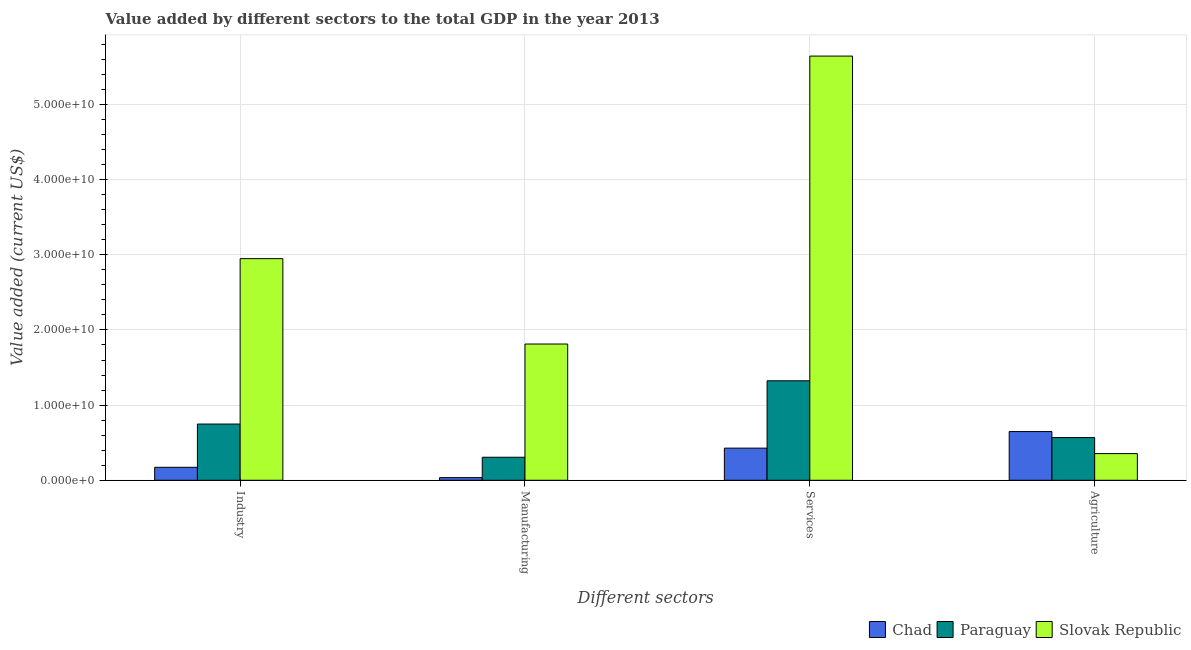How many groups of bars are there?
Ensure brevity in your answer.  4. Are the number of bars per tick equal to the number of legend labels?
Provide a short and direct response. Yes. Are the number of bars on each tick of the X-axis equal?
Give a very brief answer. Yes. How many bars are there on the 1st tick from the left?
Make the answer very short. 3. What is the label of the 4th group of bars from the left?
Your answer should be compact. Agriculture. What is the value added by manufacturing sector in Slovak Republic?
Give a very brief answer. 1.81e+1. Across all countries, what is the maximum value added by services sector?
Offer a terse response. 5.64e+1. Across all countries, what is the minimum value added by manufacturing sector?
Your response must be concise. 3.52e+08. In which country was the value added by agricultural sector maximum?
Keep it short and to the point. Chad. In which country was the value added by agricultural sector minimum?
Keep it short and to the point. Slovak Republic. What is the total value added by manufacturing sector in the graph?
Your answer should be very brief. 2.15e+1. What is the difference between the value added by services sector in Paraguay and that in Slovak Republic?
Provide a short and direct response. -4.32e+1. What is the difference between the value added by industrial sector in Slovak Republic and the value added by agricultural sector in Paraguay?
Provide a short and direct response. 2.38e+1. What is the average value added by agricultural sector per country?
Make the answer very short. 5.24e+09. What is the difference between the value added by services sector and value added by industrial sector in Slovak Republic?
Ensure brevity in your answer.  2.69e+1. What is the ratio of the value added by services sector in Chad to that in Slovak Republic?
Your answer should be very brief. 0.08. What is the difference between the highest and the second highest value added by industrial sector?
Keep it short and to the point. 2.20e+1. What is the difference between the highest and the lowest value added by manufacturing sector?
Ensure brevity in your answer.  1.78e+1. In how many countries, is the value added by services sector greater than the average value added by services sector taken over all countries?
Your response must be concise. 1. Is the sum of the value added by agricultural sector in Chad and Slovak Republic greater than the maximum value added by industrial sector across all countries?
Your answer should be very brief. No. Is it the case that in every country, the sum of the value added by manufacturing sector and value added by agricultural sector is greater than the sum of value added by services sector and value added by industrial sector?
Your answer should be compact. No. What does the 1st bar from the left in Services represents?
Offer a very short reply. Chad. What does the 2nd bar from the right in Industry represents?
Your response must be concise. Paraguay. Is it the case that in every country, the sum of the value added by industrial sector and value added by manufacturing sector is greater than the value added by services sector?
Provide a short and direct response. No. Are all the bars in the graph horizontal?
Keep it short and to the point. No. How many countries are there in the graph?
Your answer should be compact. 3. What is the difference between two consecutive major ticks on the Y-axis?
Make the answer very short. 1.00e+1. Are the values on the major ticks of Y-axis written in scientific E-notation?
Ensure brevity in your answer.  Yes. Does the graph contain grids?
Provide a short and direct response. Yes. How many legend labels are there?
Ensure brevity in your answer.  3. What is the title of the graph?
Ensure brevity in your answer.  Value added by different sectors to the total GDP in the year 2013. Does "Cote d'Ivoire" appear as one of the legend labels in the graph?
Offer a terse response. No. What is the label or title of the X-axis?
Offer a terse response. Different sectors. What is the label or title of the Y-axis?
Your response must be concise. Value added (current US$). What is the Value added (current US$) of Chad in Industry?
Make the answer very short. 1.73e+09. What is the Value added (current US$) of Paraguay in Industry?
Provide a short and direct response. 7.48e+09. What is the Value added (current US$) of Slovak Republic in Industry?
Offer a very short reply. 2.95e+1. What is the Value added (current US$) of Chad in Manufacturing?
Make the answer very short. 3.52e+08. What is the Value added (current US$) of Paraguay in Manufacturing?
Ensure brevity in your answer.  3.06e+09. What is the Value added (current US$) of Slovak Republic in Manufacturing?
Your answer should be very brief. 1.81e+1. What is the Value added (current US$) in Chad in Services?
Your answer should be very brief. 4.28e+09. What is the Value added (current US$) in Paraguay in Services?
Ensure brevity in your answer.  1.32e+1. What is the Value added (current US$) of Slovak Republic in Services?
Offer a very short reply. 5.64e+1. What is the Value added (current US$) in Chad in Agriculture?
Your response must be concise. 6.48e+09. What is the Value added (current US$) in Paraguay in Agriculture?
Your answer should be very brief. 5.68e+09. What is the Value added (current US$) in Slovak Republic in Agriculture?
Your answer should be compact. 3.55e+09. Across all Different sectors, what is the maximum Value added (current US$) in Chad?
Keep it short and to the point. 6.48e+09. Across all Different sectors, what is the maximum Value added (current US$) of Paraguay?
Provide a succinct answer. 1.32e+1. Across all Different sectors, what is the maximum Value added (current US$) in Slovak Republic?
Provide a short and direct response. 5.64e+1. Across all Different sectors, what is the minimum Value added (current US$) of Chad?
Provide a short and direct response. 3.52e+08. Across all Different sectors, what is the minimum Value added (current US$) in Paraguay?
Your answer should be compact. 3.06e+09. Across all Different sectors, what is the minimum Value added (current US$) in Slovak Republic?
Offer a terse response. 3.55e+09. What is the total Value added (current US$) of Chad in the graph?
Provide a succinct answer. 1.28e+1. What is the total Value added (current US$) of Paraguay in the graph?
Give a very brief answer. 2.95e+1. What is the total Value added (current US$) in Slovak Republic in the graph?
Your answer should be compact. 1.08e+11. What is the difference between the Value added (current US$) of Chad in Industry and that in Manufacturing?
Your response must be concise. 1.37e+09. What is the difference between the Value added (current US$) in Paraguay in Industry and that in Manufacturing?
Offer a very short reply. 4.42e+09. What is the difference between the Value added (current US$) of Slovak Republic in Industry and that in Manufacturing?
Offer a very short reply. 1.14e+1. What is the difference between the Value added (current US$) of Chad in Industry and that in Services?
Your answer should be compact. -2.55e+09. What is the difference between the Value added (current US$) of Paraguay in Industry and that in Services?
Your response must be concise. -5.75e+09. What is the difference between the Value added (current US$) in Slovak Republic in Industry and that in Services?
Provide a succinct answer. -2.69e+1. What is the difference between the Value added (current US$) in Chad in Industry and that in Agriculture?
Offer a terse response. -4.75e+09. What is the difference between the Value added (current US$) of Paraguay in Industry and that in Agriculture?
Keep it short and to the point. 1.80e+09. What is the difference between the Value added (current US$) of Slovak Republic in Industry and that in Agriculture?
Ensure brevity in your answer.  2.59e+1. What is the difference between the Value added (current US$) of Chad in Manufacturing and that in Services?
Provide a short and direct response. -3.92e+09. What is the difference between the Value added (current US$) of Paraguay in Manufacturing and that in Services?
Give a very brief answer. -1.02e+1. What is the difference between the Value added (current US$) in Slovak Republic in Manufacturing and that in Services?
Give a very brief answer. -3.83e+1. What is the difference between the Value added (current US$) of Chad in Manufacturing and that in Agriculture?
Your response must be concise. -6.13e+09. What is the difference between the Value added (current US$) of Paraguay in Manufacturing and that in Agriculture?
Ensure brevity in your answer.  -2.62e+09. What is the difference between the Value added (current US$) of Slovak Republic in Manufacturing and that in Agriculture?
Make the answer very short. 1.46e+1. What is the difference between the Value added (current US$) in Chad in Services and that in Agriculture?
Make the answer very short. -2.20e+09. What is the difference between the Value added (current US$) in Paraguay in Services and that in Agriculture?
Keep it short and to the point. 7.55e+09. What is the difference between the Value added (current US$) of Slovak Republic in Services and that in Agriculture?
Your response must be concise. 5.29e+1. What is the difference between the Value added (current US$) of Chad in Industry and the Value added (current US$) of Paraguay in Manufacturing?
Keep it short and to the point. -1.34e+09. What is the difference between the Value added (current US$) of Chad in Industry and the Value added (current US$) of Slovak Republic in Manufacturing?
Your response must be concise. -1.64e+1. What is the difference between the Value added (current US$) in Paraguay in Industry and the Value added (current US$) in Slovak Republic in Manufacturing?
Your answer should be very brief. -1.06e+1. What is the difference between the Value added (current US$) of Chad in Industry and the Value added (current US$) of Paraguay in Services?
Offer a very short reply. -1.15e+1. What is the difference between the Value added (current US$) of Chad in Industry and the Value added (current US$) of Slovak Republic in Services?
Offer a very short reply. -5.47e+1. What is the difference between the Value added (current US$) in Paraguay in Industry and the Value added (current US$) in Slovak Republic in Services?
Provide a short and direct response. -4.90e+1. What is the difference between the Value added (current US$) of Chad in Industry and the Value added (current US$) of Paraguay in Agriculture?
Provide a succinct answer. -3.96e+09. What is the difference between the Value added (current US$) of Chad in Industry and the Value added (current US$) of Slovak Republic in Agriculture?
Offer a very short reply. -1.82e+09. What is the difference between the Value added (current US$) in Paraguay in Industry and the Value added (current US$) in Slovak Republic in Agriculture?
Your response must be concise. 3.93e+09. What is the difference between the Value added (current US$) of Chad in Manufacturing and the Value added (current US$) of Paraguay in Services?
Your answer should be compact. -1.29e+1. What is the difference between the Value added (current US$) of Chad in Manufacturing and the Value added (current US$) of Slovak Republic in Services?
Keep it short and to the point. -5.61e+1. What is the difference between the Value added (current US$) in Paraguay in Manufacturing and the Value added (current US$) in Slovak Republic in Services?
Provide a short and direct response. -5.34e+1. What is the difference between the Value added (current US$) of Chad in Manufacturing and the Value added (current US$) of Paraguay in Agriculture?
Keep it short and to the point. -5.33e+09. What is the difference between the Value added (current US$) in Chad in Manufacturing and the Value added (current US$) in Slovak Republic in Agriculture?
Provide a succinct answer. -3.20e+09. What is the difference between the Value added (current US$) of Paraguay in Manufacturing and the Value added (current US$) of Slovak Republic in Agriculture?
Offer a terse response. -4.87e+08. What is the difference between the Value added (current US$) of Chad in Services and the Value added (current US$) of Paraguay in Agriculture?
Offer a very short reply. -1.41e+09. What is the difference between the Value added (current US$) in Chad in Services and the Value added (current US$) in Slovak Republic in Agriculture?
Your response must be concise. 7.26e+08. What is the difference between the Value added (current US$) of Paraguay in Services and the Value added (current US$) of Slovak Republic in Agriculture?
Your response must be concise. 9.68e+09. What is the average Value added (current US$) in Chad per Different sectors?
Make the answer very short. 3.21e+09. What is the average Value added (current US$) of Paraguay per Different sectors?
Provide a short and direct response. 7.36e+09. What is the average Value added (current US$) of Slovak Republic per Different sectors?
Provide a short and direct response. 2.69e+1. What is the difference between the Value added (current US$) in Chad and Value added (current US$) in Paraguay in Industry?
Offer a very short reply. -5.75e+09. What is the difference between the Value added (current US$) in Chad and Value added (current US$) in Slovak Republic in Industry?
Your answer should be very brief. -2.78e+1. What is the difference between the Value added (current US$) of Paraguay and Value added (current US$) of Slovak Republic in Industry?
Offer a very short reply. -2.20e+1. What is the difference between the Value added (current US$) of Chad and Value added (current US$) of Paraguay in Manufacturing?
Make the answer very short. -2.71e+09. What is the difference between the Value added (current US$) of Chad and Value added (current US$) of Slovak Republic in Manufacturing?
Ensure brevity in your answer.  -1.78e+1. What is the difference between the Value added (current US$) of Paraguay and Value added (current US$) of Slovak Republic in Manufacturing?
Keep it short and to the point. -1.51e+1. What is the difference between the Value added (current US$) of Chad and Value added (current US$) of Paraguay in Services?
Your response must be concise. -8.96e+09. What is the difference between the Value added (current US$) in Chad and Value added (current US$) in Slovak Republic in Services?
Provide a short and direct response. -5.22e+1. What is the difference between the Value added (current US$) in Paraguay and Value added (current US$) in Slovak Republic in Services?
Keep it short and to the point. -4.32e+1. What is the difference between the Value added (current US$) of Chad and Value added (current US$) of Paraguay in Agriculture?
Your response must be concise. 7.98e+08. What is the difference between the Value added (current US$) of Chad and Value added (current US$) of Slovak Republic in Agriculture?
Provide a short and direct response. 2.93e+09. What is the difference between the Value added (current US$) in Paraguay and Value added (current US$) in Slovak Republic in Agriculture?
Offer a very short reply. 2.13e+09. What is the ratio of the Value added (current US$) in Chad in Industry to that in Manufacturing?
Provide a short and direct response. 4.9. What is the ratio of the Value added (current US$) of Paraguay in Industry to that in Manufacturing?
Provide a succinct answer. 2.44. What is the ratio of the Value added (current US$) in Slovak Republic in Industry to that in Manufacturing?
Ensure brevity in your answer.  1.63. What is the ratio of the Value added (current US$) of Chad in Industry to that in Services?
Your answer should be compact. 0.4. What is the ratio of the Value added (current US$) in Paraguay in Industry to that in Services?
Offer a terse response. 0.57. What is the ratio of the Value added (current US$) in Slovak Republic in Industry to that in Services?
Provide a short and direct response. 0.52. What is the ratio of the Value added (current US$) of Chad in Industry to that in Agriculture?
Your answer should be very brief. 0.27. What is the ratio of the Value added (current US$) in Paraguay in Industry to that in Agriculture?
Offer a very short reply. 1.32. What is the ratio of the Value added (current US$) in Slovak Republic in Industry to that in Agriculture?
Your response must be concise. 8.31. What is the ratio of the Value added (current US$) of Chad in Manufacturing to that in Services?
Offer a very short reply. 0.08. What is the ratio of the Value added (current US$) of Paraguay in Manufacturing to that in Services?
Make the answer very short. 0.23. What is the ratio of the Value added (current US$) in Slovak Republic in Manufacturing to that in Services?
Keep it short and to the point. 0.32. What is the ratio of the Value added (current US$) of Chad in Manufacturing to that in Agriculture?
Your answer should be compact. 0.05. What is the ratio of the Value added (current US$) in Paraguay in Manufacturing to that in Agriculture?
Provide a short and direct response. 0.54. What is the ratio of the Value added (current US$) in Slovak Republic in Manufacturing to that in Agriculture?
Your answer should be very brief. 5.11. What is the ratio of the Value added (current US$) of Chad in Services to that in Agriculture?
Your answer should be compact. 0.66. What is the ratio of the Value added (current US$) of Paraguay in Services to that in Agriculture?
Give a very brief answer. 2.33. What is the ratio of the Value added (current US$) of Slovak Republic in Services to that in Agriculture?
Ensure brevity in your answer.  15.9. What is the difference between the highest and the second highest Value added (current US$) in Chad?
Your answer should be compact. 2.20e+09. What is the difference between the highest and the second highest Value added (current US$) in Paraguay?
Give a very brief answer. 5.75e+09. What is the difference between the highest and the second highest Value added (current US$) in Slovak Republic?
Provide a short and direct response. 2.69e+1. What is the difference between the highest and the lowest Value added (current US$) of Chad?
Your answer should be compact. 6.13e+09. What is the difference between the highest and the lowest Value added (current US$) in Paraguay?
Offer a terse response. 1.02e+1. What is the difference between the highest and the lowest Value added (current US$) in Slovak Republic?
Provide a succinct answer. 5.29e+1. 